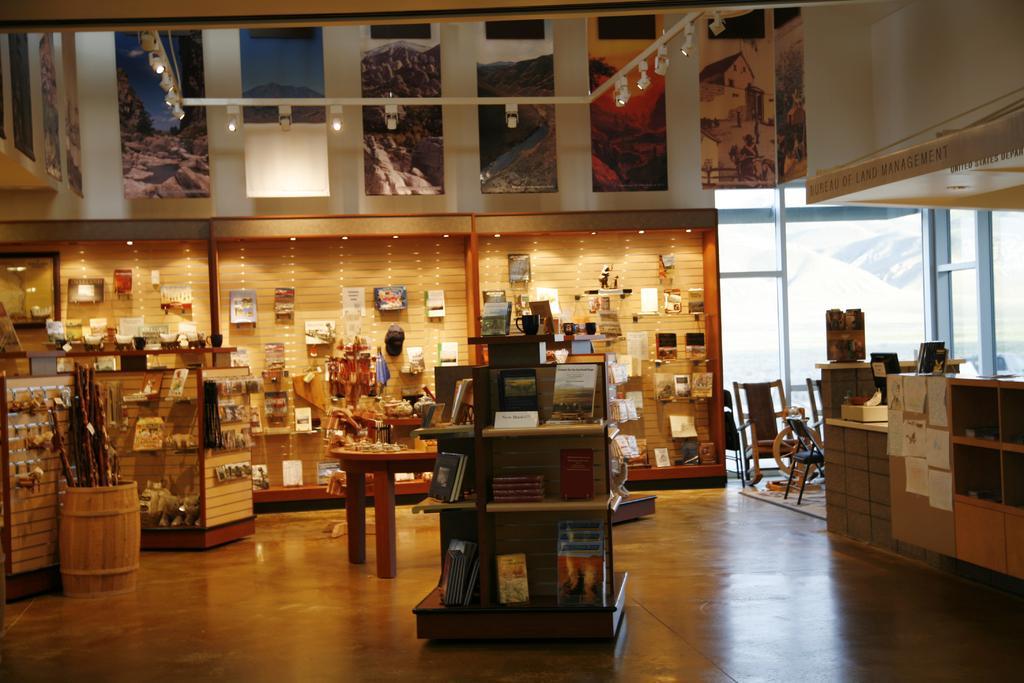Can you describe this image briefly? In this picture, There is a floor which is in yellow color, In the middle there is a table in that there are some objects kept, In the right side there are some tables which are in white and yellow color, In the left side there are some yellow color objects, In the background there is a yellow color and there are pictures on the wall, In the top there are some poster and there are some light which are in white color hanging on the roof. 